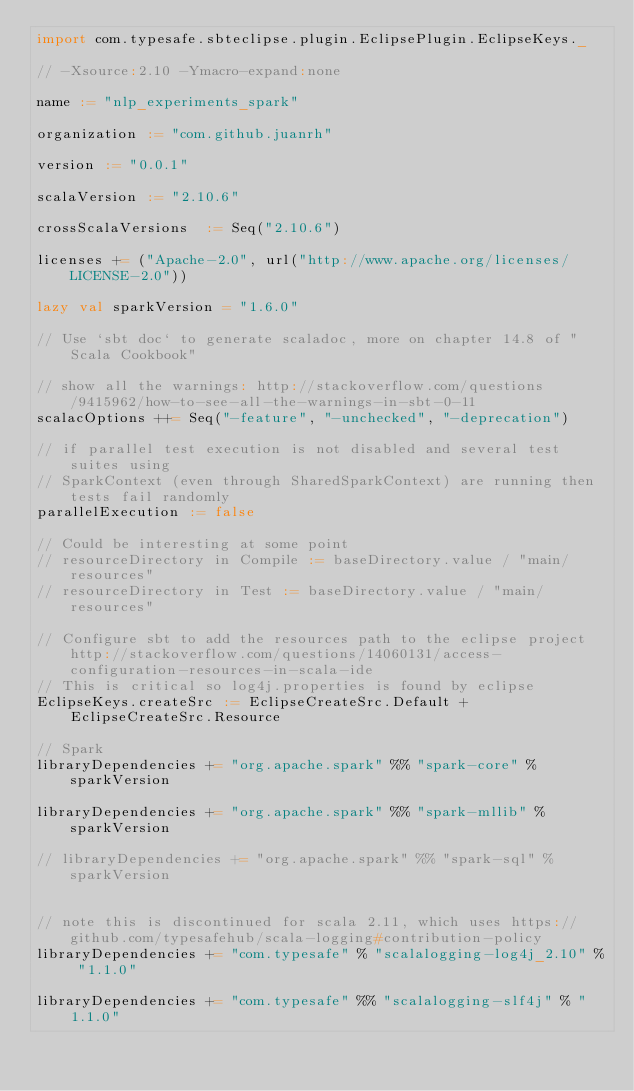<code> <loc_0><loc_0><loc_500><loc_500><_Scala_>import com.typesafe.sbteclipse.plugin.EclipsePlugin.EclipseKeys._

// -Xsource:2.10 -Ymacro-expand:none

name := "nlp_experiments_spark"

organization := "com.github.juanrh"

version := "0.0.1" 

scalaVersion := "2.10.6"

crossScalaVersions  := Seq("2.10.6")

licenses += ("Apache-2.0", url("http://www.apache.org/licenses/LICENSE-2.0"))

lazy val sparkVersion = "1.6.0"

// Use `sbt doc` to generate scaladoc, more on chapter 14.8 of "Scala Cookbook"

// show all the warnings: http://stackoverflow.com/questions/9415962/how-to-see-all-the-warnings-in-sbt-0-11
scalacOptions ++= Seq("-feature", "-unchecked", "-deprecation")

// if parallel test execution is not disabled and several test suites using
// SparkContext (even through SharedSparkContext) are running then tests fail randomly
parallelExecution := false

// Could be interesting at some point
// resourceDirectory in Compile := baseDirectory.value / "main/resources"
// resourceDirectory in Test := baseDirectory.value / "main/resources"

// Configure sbt to add the resources path to the eclipse project http://stackoverflow.com/questions/14060131/access-configuration-resources-in-scala-ide
// This is critical so log4j.properties is found by eclipse
EclipseKeys.createSrc := EclipseCreateSrc.Default + EclipseCreateSrc.Resource

// Spark 
libraryDependencies += "org.apache.spark" %% "spark-core" % sparkVersion

libraryDependencies += "org.apache.spark" %% "spark-mllib" % sparkVersion

// libraryDependencies += "org.apache.spark" %% "spark-sql" % sparkVersion


// note this is discontinued for scala 2.11, which uses https://github.com/typesafehub/scala-logging#contribution-policy
libraryDependencies += "com.typesafe" % "scalalogging-log4j_2.10" % "1.1.0"

libraryDependencies += "com.typesafe" %% "scalalogging-slf4j" % "1.1.0"
</code> 